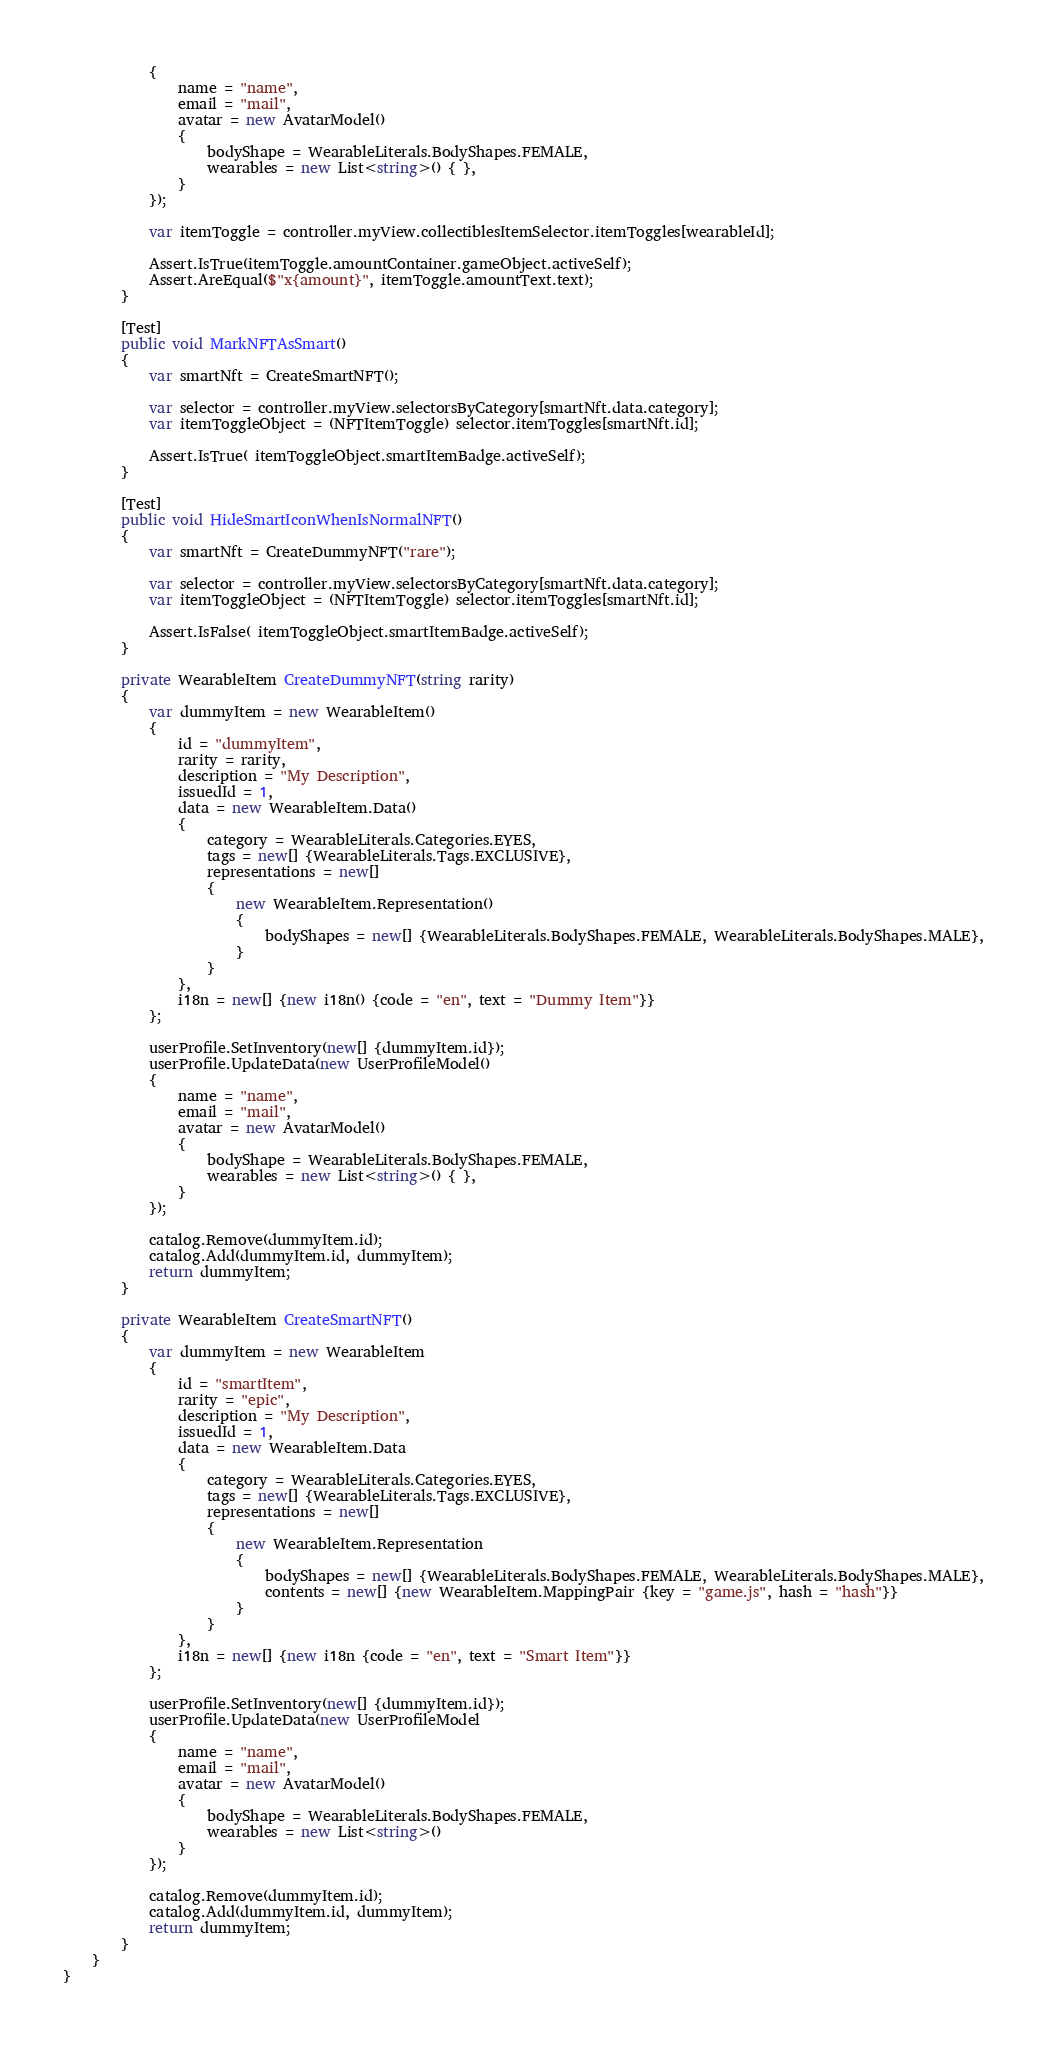<code> <loc_0><loc_0><loc_500><loc_500><_C#_>            {
                name = "name",
                email = "mail",
                avatar = new AvatarModel()
                {
                    bodyShape = WearableLiterals.BodyShapes.FEMALE,
                    wearables = new List<string>() { },
                }
            });

            var itemToggle = controller.myView.collectiblesItemSelector.itemToggles[wearableId];

            Assert.IsTrue(itemToggle.amountContainer.gameObject.activeSelf);
            Assert.AreEqual($"x{amount}", itemToggle.amountText.text);
        }

        [Test]
        public void MarkNFTAsSmart()
        {
            var smartNft = CreateSmartNFT();

            var selector = controller.myView.selectorsByCategory[smartNft.data.category];
            var itemToggleObject = (NFTItemToggle) selector.itemToggles[smartNft.id];

            Assert.IsTrue( itemToggleObject.smartItemBadge.activeSelf);
        }
        
        [Test]
        public void HideSmartIconWhenIsNormalNFT()
        {
            var smartNft = CreateDummyNFT("rare");

            var selector = controller.myView.selectorsByCategory[smartNft.data.category];
            var itemToggleObject = (NFTItemToggle) selector.itemToggles[smartNft.id];

            Assert.IsFalse( itemToggleObject.smartItemBadge.activeSelf);
        }

        private WearableItem CreateDummyNFT(string rarity)
        {
            var dummyItem = new WearableItem()
            {
                id = "dummyItem",
                rarity = rarity,
                description = "My Description",
                issuedId = 1,
                data = new WearableItem.Data()
                {
                    category = WearableLiterals.Categories.EYES,
                    tags = new[] {WearableLiterals.Tags.EXCLUSIVE},
                    representations = new[]
                    {
                        new WearableItem.Representation()
                        {
                            bodyShapes = new[] {WearableLiterals.BodyShapes.FEMALE, WearableLiterals.BodyShapes.MALE},
                        }
                    }
                },
                i18n = new[] {new i18n() {code = "en", text = "Dummy Item"}}
            };

            userProfile.SetInventory(new[] {dummyItem.id});
            userProfile.UpdateData(new UserProfileModel()
            {
                name = "name",
                email = "mail",
                avatar = new AvatarModel()
                {
                    bodyShape = WearableLiterals.BodyShapes.FEMALE,
                    wearables = new List<string>() { },
                }
            });

            catalog.Remove(dummyItem.id);
            catalog.Add(dummyItem.id, dummyItem);
            return dummyItem;
        }

        private WearableItem CreateSmartNFT()
        {
            var dummyItem = new WearableItem
            {
                id = "smartItem",
                rarity = "epic",
                description = "My Description",
                issuedId = 1,
                data = new WearableItem.Data
                {
                    category = WearableLiterals.Categories.EYES,
                    tags = new[] {WearableLiterals.Tags.EXCLUSIVE},
                    representations = new[]
                    {
                        new WearableItem.Representation
                        {
                            bodyShapes = new[] {WearableLiterals.BodyShapes.FEMALE, WearableLiterals.BodyShapes.MALE},
                            contents = new[] {new WearableItem.MappingPair {key = "game.js", hash = "hash"}}
                        }
                    }
                },
                i18n = new[] {new i18n {code = "en", text = "Smart Item"}}
            };

            userProfile.SetInventory(new[] {dummyItem.id});
            userProfile.UpdateData(new UserProfileModel
            {
                name = "name",
                email = "mail",
                avatar = new AvatarModel()
                {
                    bodyShape = WearableLiterals.BodyShapes.FEMALE,
                    wearables = new List<string>()
                }
            });

            catalog.Remove(dummyItem.id);
            catalog.Add(dummyItem.id, dummyItem);
            return dummyItem;
        }
    }
}</code> 